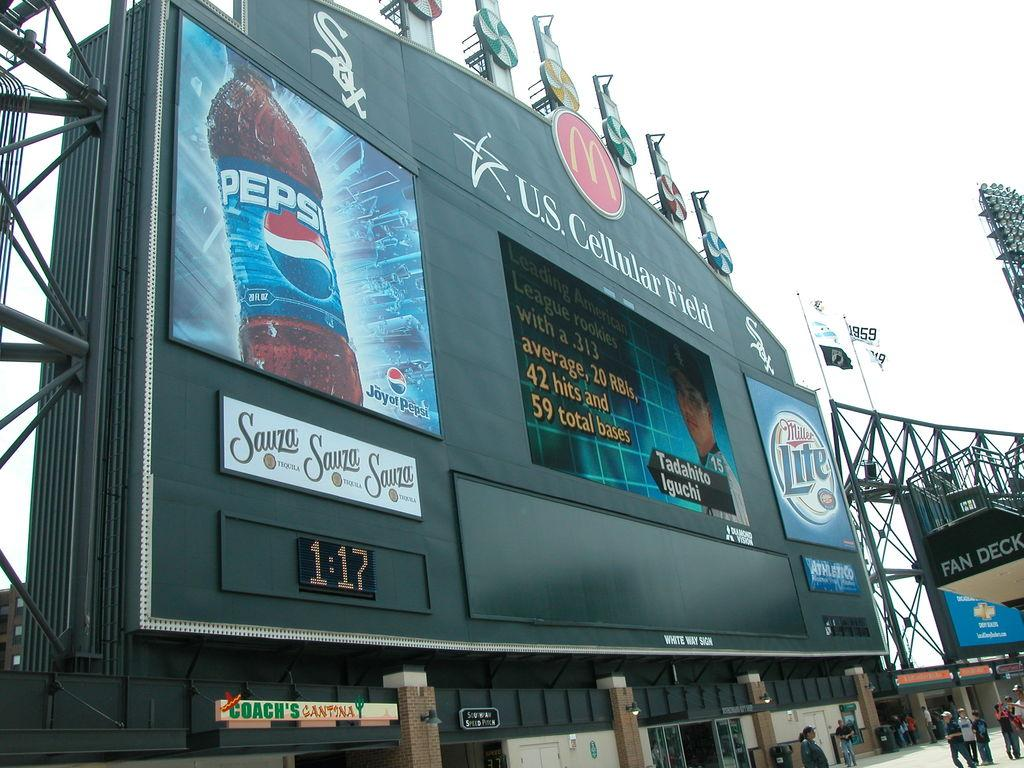<image>
Relay a brief, clear account of the picture shown. a us cellular score board with the time 1:17 